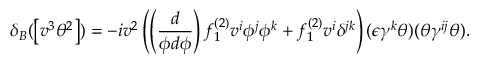Convert formula to latex. <formula><loc_0><loc_0><loc_500><loc_500>\delta _ { B } ( \left [ v ^ { 3 } \theta ^ { 2 } \right ] ) = - i v ^ { 2 } \left ( \left ( \frac { d } { \phi d \phi } \right ) f _ { 1 } ^ { ( 2 ) } v ^ { i } \phi ^ { j } \phi ^ { k } + f _ { 1 } ^ { ( 2 ) } v ^ { i } \delta ^ { j k } \right ) ( \epsilon \gamma ^ { k } \theta ) ( \theta \gamma ^ { i j } \theta ) .</formula> 